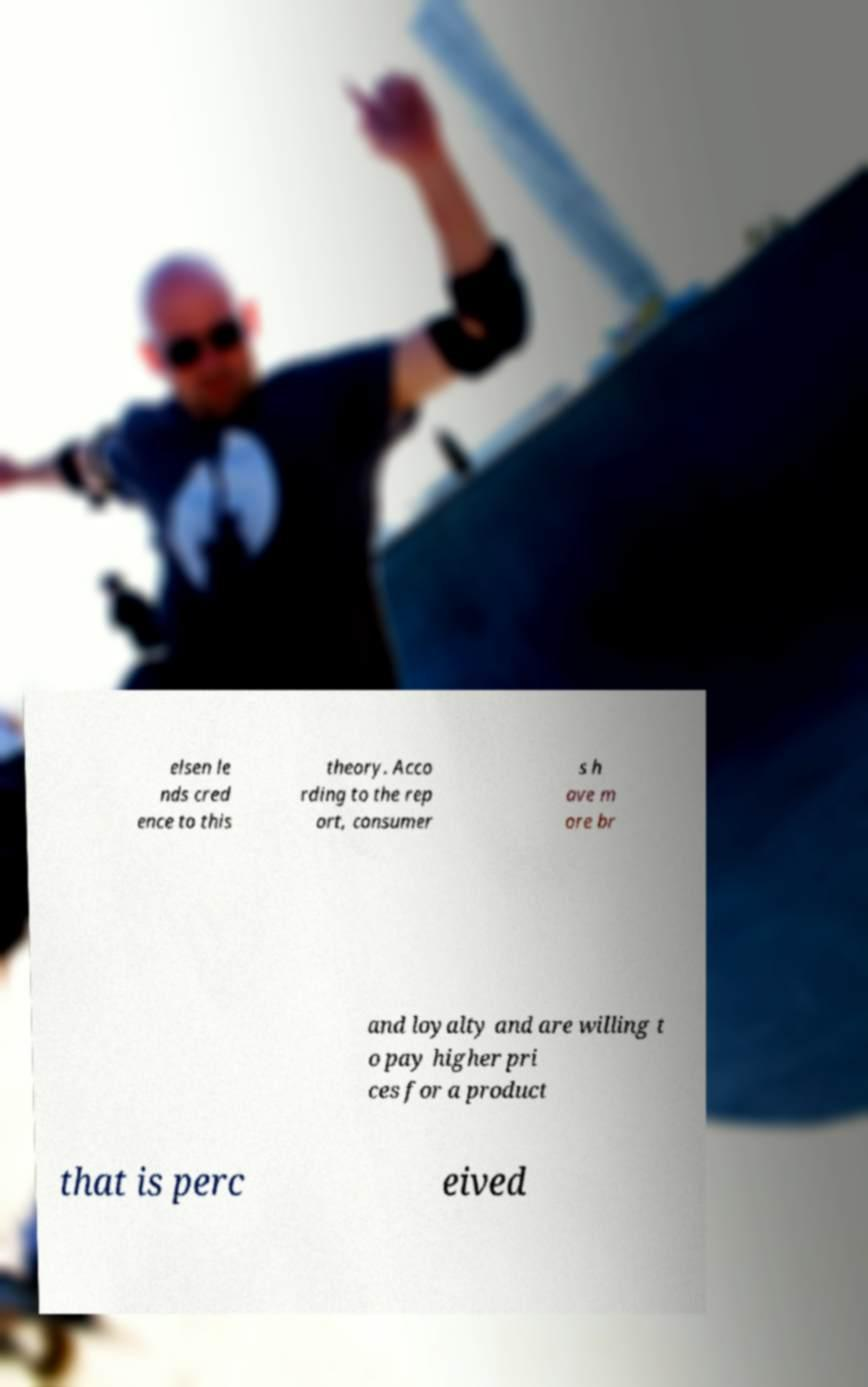What messages or text are displayed in this image? I need them in a readable, typed format. elsen le nds cred ence to this theory. Acco rding to the rep ort, consumer s h ave m ore br and loyalty and are willing t o pay higher pri ces for a product that is perc eived 